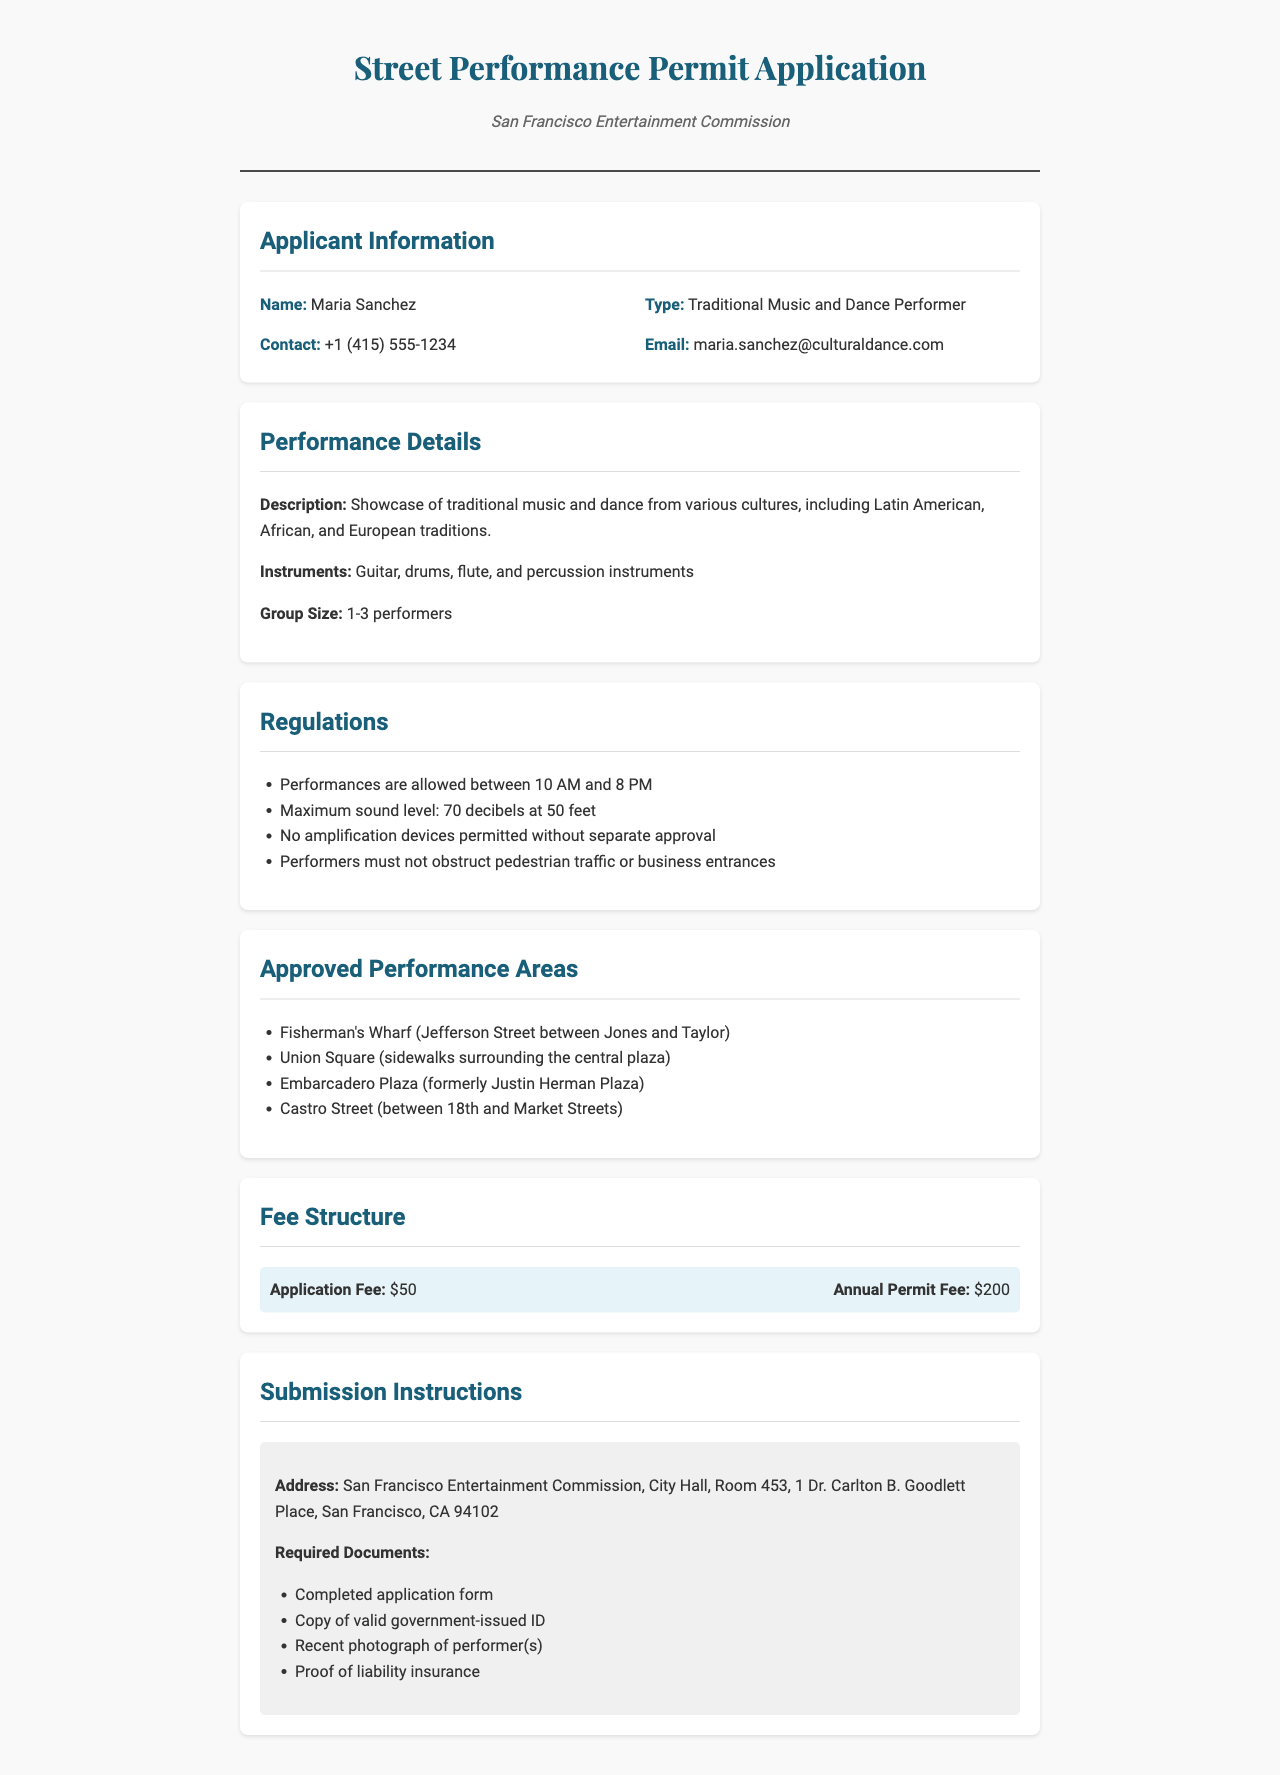What is the applicant's name? The applicant's name is provided in the applicant information section of the document.
Answer: Maria Sanchez What is the type of performance? The type of performance is mentioned in the applicant information section of the document.
Answer: Traditional Music and Dance Performer What is the maximum sound level allowed? The maximum sound level is specified in the regulations section of the document.
Answer: 70 decibels at 50 feet What is the application fee? The application fee is listed in the fee structure section of the document.
Answer: $50 Which area is approved for performances? The approved performance areas are outlined in a list within the document.
Answer: Fisherman's Wharf What time are performances allowed to start? The regulations specify the allowed performance hours.
Answer: 10 AM How many performers are allowed in the group size? The group size information is described in the performance details section of the document.
Answer: 1-3 performers What address should applications be sent to? The submission instructions provide the address for sending applications.
Answer: San Francisco Entertainment Commission, City Hall, Room 453, 1 Dr. Carlton B. Goodlett Place, San Francisco, CA 94102 What is required alongside the application? The submission instructions detail the required documents to submit with the application.
Answer: Completed application form 